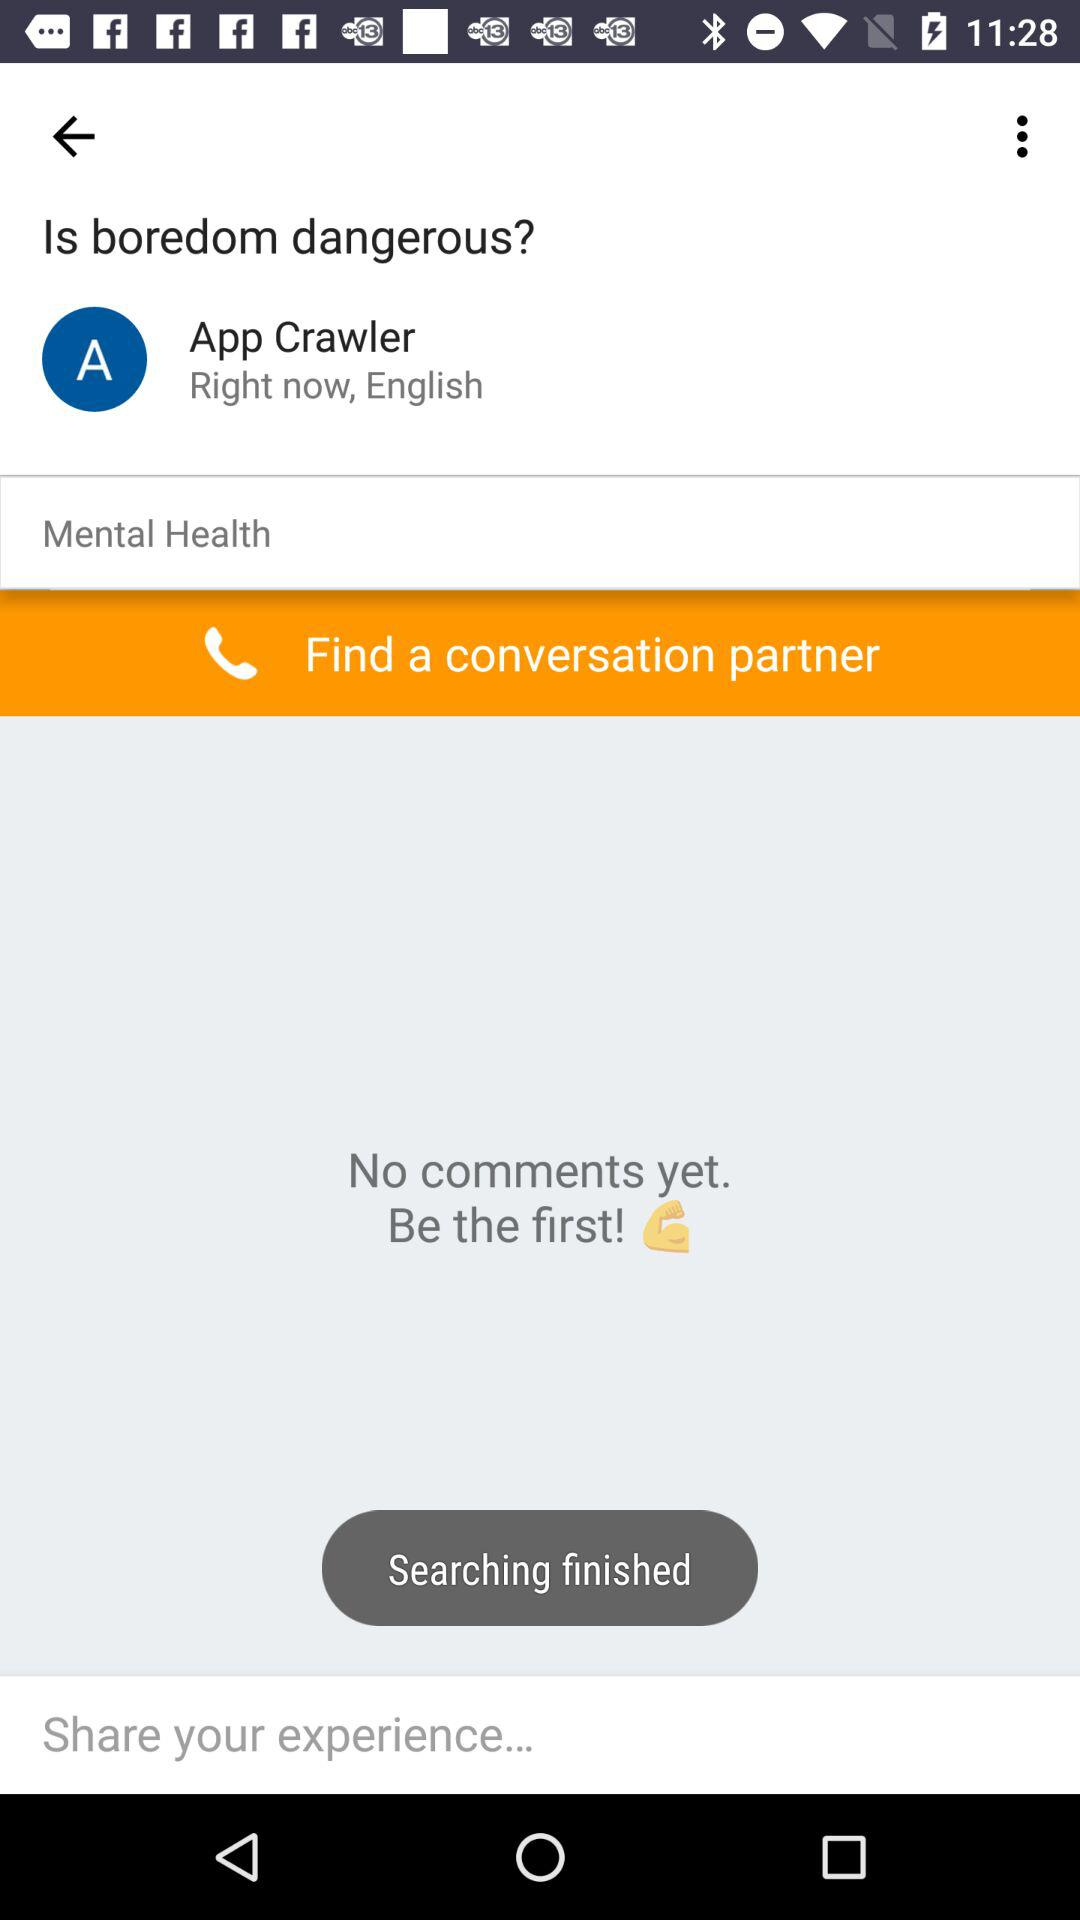How many comments are there? The image depicts a screen from a forum or an app indicating that there are currently no comments on the post titled 'Is boredom dangerous?'. It invites users to be the first to comment. 